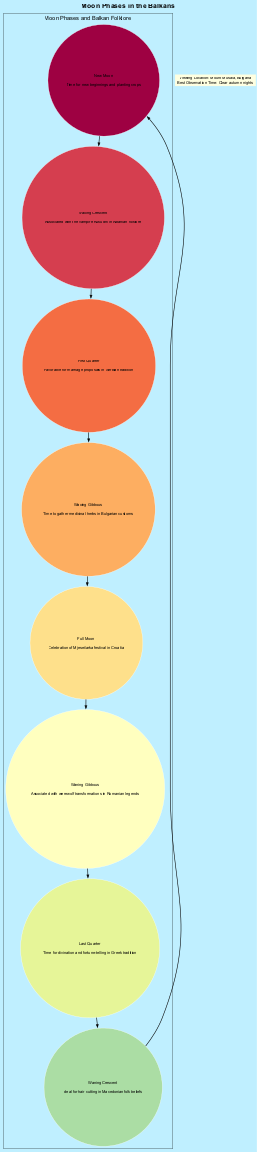What is the folklore associated with the Full Moon phase? The diagram states that the Full Moon phase is associated with the celebration of the Mjesečarka festival in Croatia. This information is located in the section corresponding to the Full Moon phase.
Answer: Celebration of Mjesečarka festival in Croatia How many moon phases are illustrated in the diagram? By counting the individual phases listed in the diagram, I notice there are eight distinct phases shown, each with its folklore linked.
Answer: 8 Which phase is linked to divination and fortune-telling? According to the diagram, the Last Quarter phase is associated with divination and fortune-telling, as stated in the folklore for that phase. This can be directly found in the section discussing the Last Quarter.
Answer: Last Quarter What is the viewing location recommended for observing the moon phases? The diagram specifies the viewing location as Mount Musala in Bulgaria, which is included in the additional information section at the bottom of the diagram.
Answer: Mount Musala, Bulgaria In which moon phase is hair cutting considered ideal according to the diagram? The diagram directly indicates that the Waning Crescent phase is considered ideal for hair cutting based on Macedonian folk beliefs. This is recognized within its respective node.
Answer: Waning Crescent What folklore is connected with the Waxing Gibbous phase? The Waxing Gibbous phase is associated with the gathering of medicinal herbs in Bulgarian customs as indicated in the diagram. This folklore is presented specifically with that phase's information.
Answer: Time to gather medicinal herbs in Bulgarian customs Which phase is favorable for marriage proposals? As mentioned in the diagram, the First Quarter phase is noted as favorable for marriage proposals in Serbian tradition. This is clearly stated within the First Quarter's description.
Answer: First Quarter Which two phases are associated with transformations or changes in folklore? The Waning Gibbous phase, associated with werewolf transformations in Romanian legends, and the New Moon phase, linked to new beginnings and planting crops, both feature elements of transformation or change. This can be deduced by looking at the folklore linked with both phases.
Answer: Waning Gibbous and New Moon 